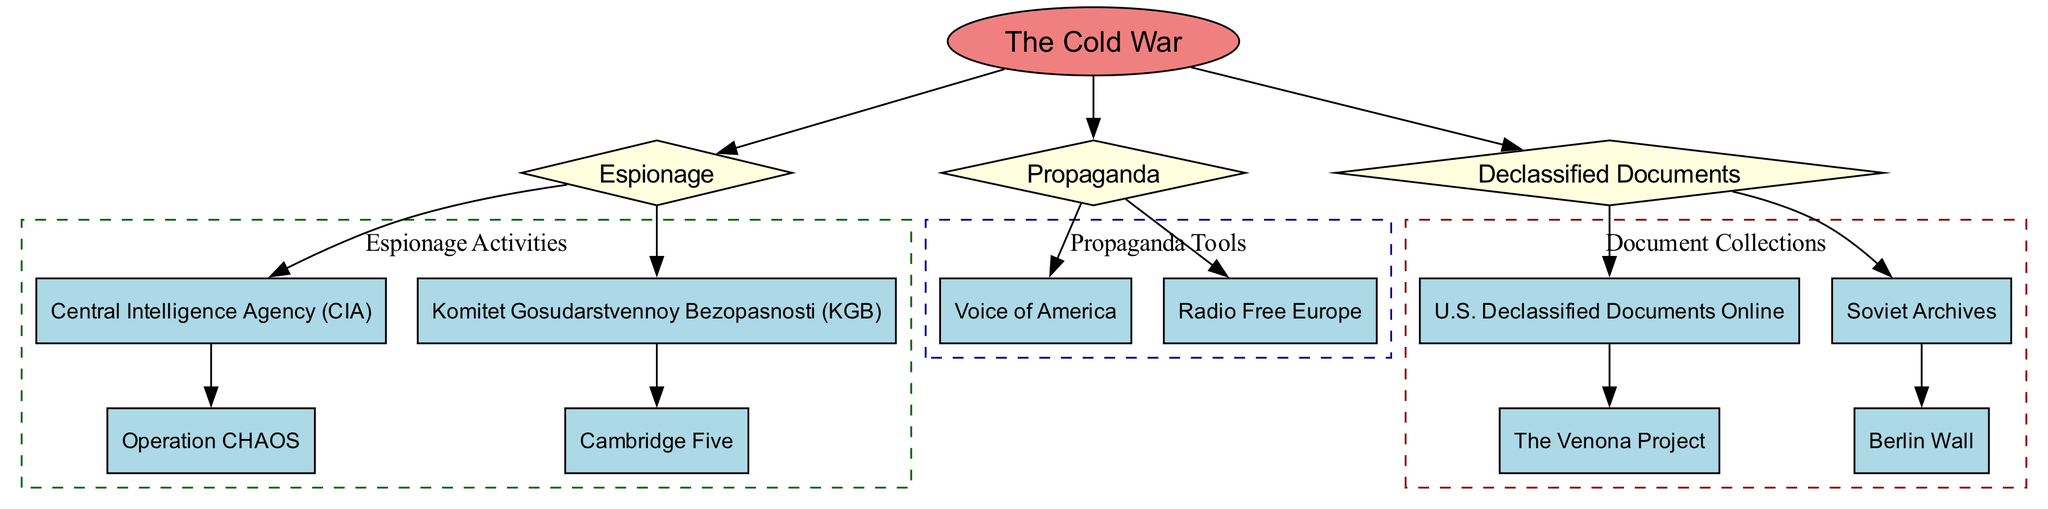What is the main focus of the concept map? The concept map highlights the Cold War and its associated themes including espionage, propaganda, and declassified documents. The central node "The Cold War" connects to these three main themes.
Answer: The Cold War How many main themes are connected to the Cold War? The diagram shows three main themes connected to the Cold War: Espionage, Propaganda, and Declassified Documents. This can be counted directly from the edges that flow from the Cold War node.
Answer: 3 Which organization is associated with Operation CHAOS? The diagram indicates that Operation CHAOS is a component of the CIA. This is illustrated by an edge connecting the CIA node to the Operation CHAOS node.
Answer: CIA Name one tool of propaganda mentioned in the diagram. The map highlights two propaganda tools, Voice of America and Radio Free Europe. Both are distinctly connected to the Propaganda node. Any one of them is a valid answer.
Answer: Voice of America Which spy group is linked to the KGB in the context of the Cold War? The Cambridge Five is specifically connected to the KGB as shown by the direct edge linking the two nodes in the espionage section of the diagram.
Answer: Cambridge Five What type of documents does the U.S. Declassified Documents Online include? The diagram connects the U.S. Declassified Documents Online to the Venona Project, which suggests that this project is part of the collection of U.S. declassified documents.
Answer: Venona Project How many document collections are represented in the diagram? The diagram contains two document collections represented by the U.S. Declassified Documents Online and Soviet Archives. These can be directly counted in the document cluster of the concept map.
Answer: 2 Which wall is referenced in relation to the Soviet document collection? The Berlin Wall is explicitly linked to the Soviet Archives node, indicating a connection between this document collection and the historical significance of the Berlin Wall.
Answer: Berlin Wall What are the two main organizations associated with espionage during the Cold War? The diagram specifically highlights two organizations: the CIA and the KGB. These connections can be directly observed under the Espionage section of the map.
Answer: CIA and KGB 